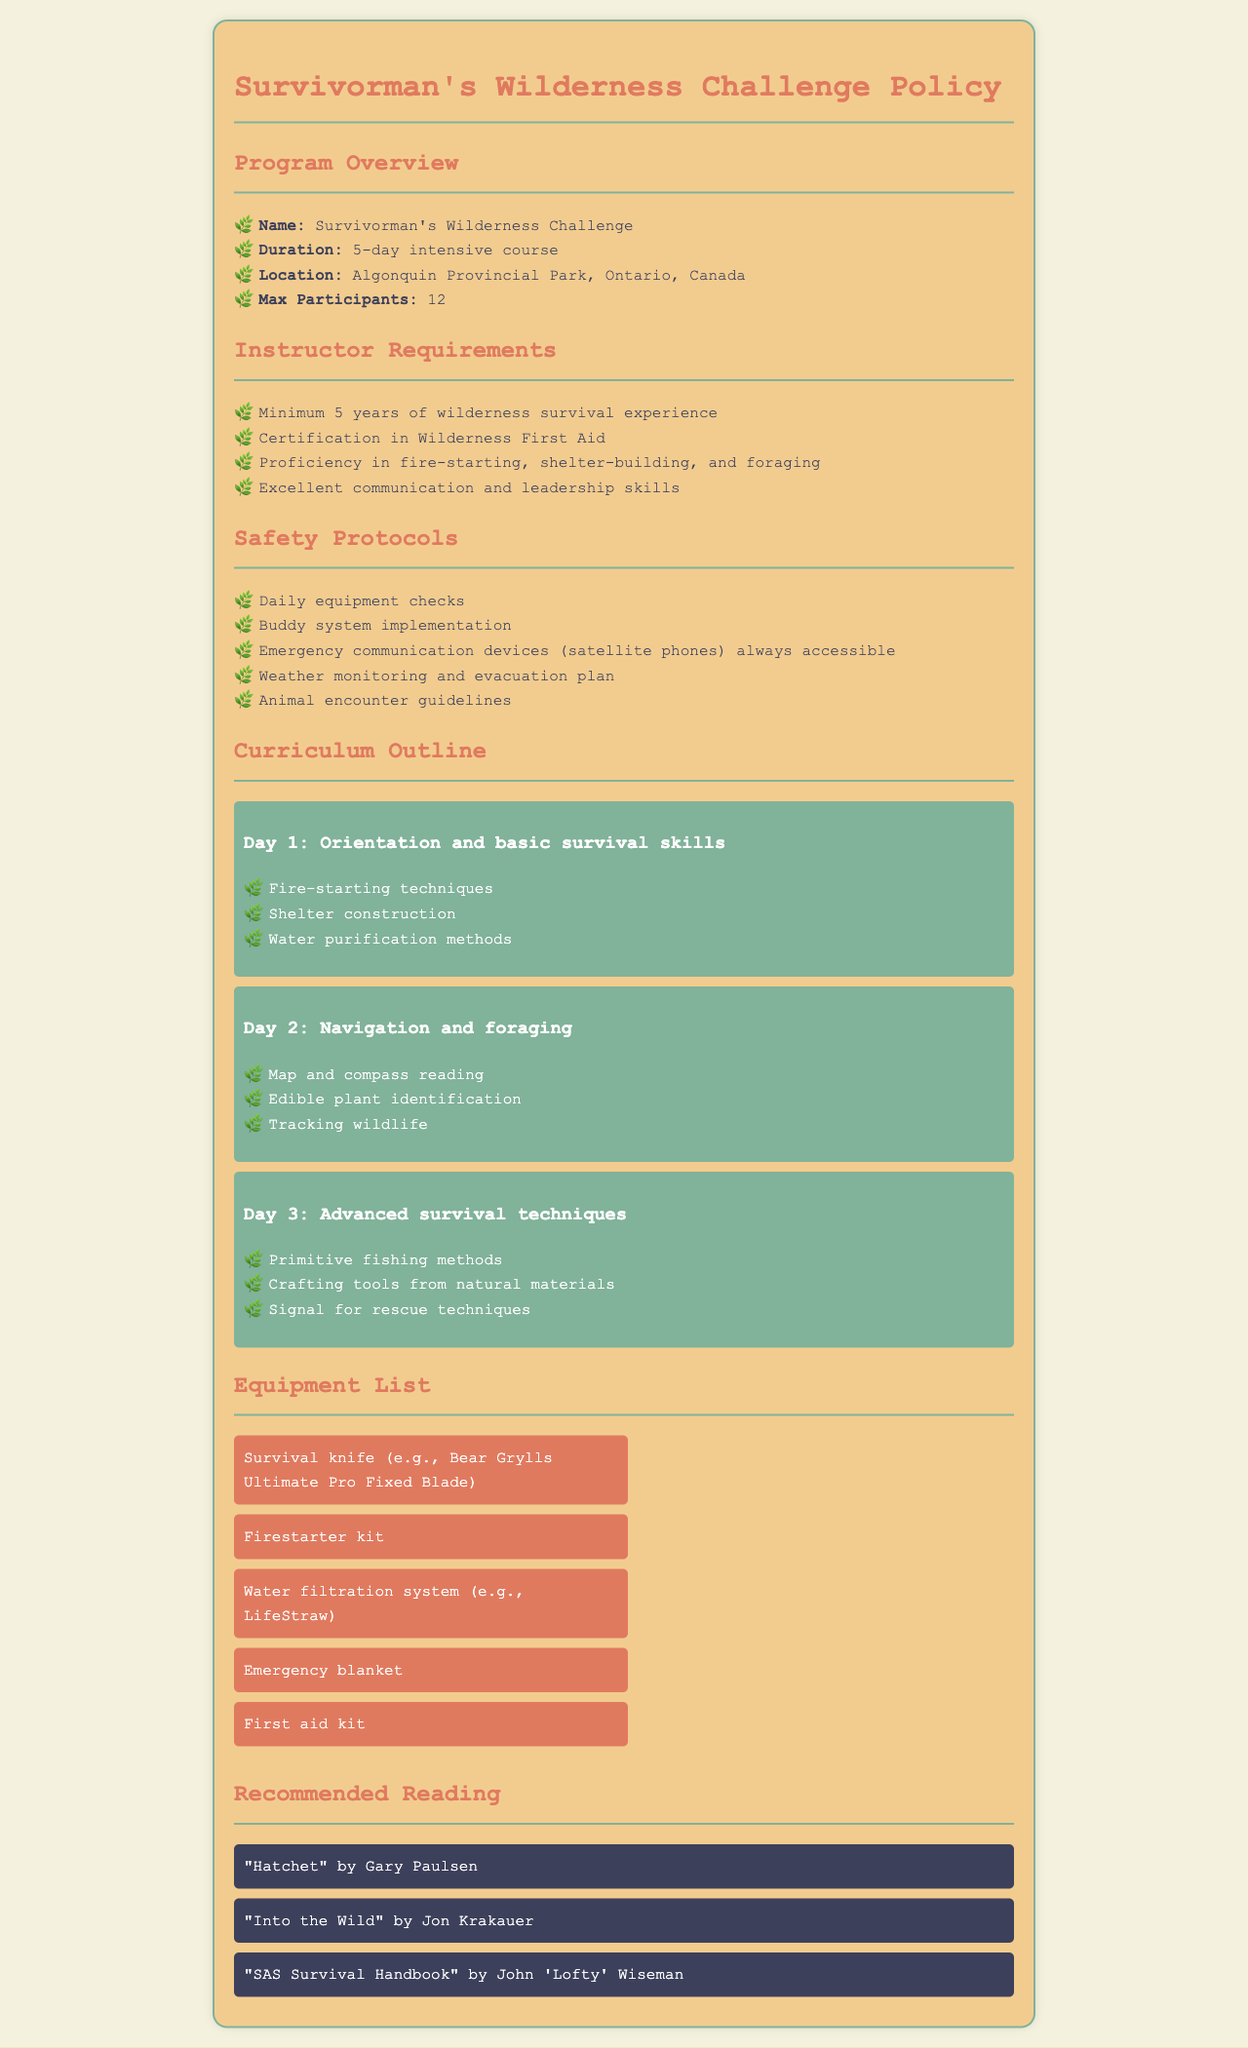what is the name of the program? The name of the program is provided in the document, which is "Survivorman's Wilderness Challenge."
Answer: Survivorman's Wilderness Challenge how many days is the training course? The duration of the training program is mentioned clearly as "5-day intensive course."
Answer: 5-day where is the training located? The document specifies the location of the program as "Algonquin Provincial Park, Ontario, Canada."
Answer: Algonquin Provincial Park, Ontario, Canada what is a requirement for instructors? The document lists various requirements for instructors, one of which includes having "Minimum 5 years of wilderness survival experience."
Answer: Minimum 5 years of wilderness survival experience what emergency equipment is always accessible? The document mentions the need for "Emergency communication devices (satellite phones) always accessible" as a safety protocol.
Answer: satellite phones which technique is taught on Day 1? The curriculum outline specifies that "Fire-starting techniques" are taught on Day 1.
Answer: Fire-starting techniques how many max participants are allowed? The document states the maximum number of participants as "12."
Answer: 12 name a recommended reading book. The document provides several titles, including "SAS Survival Handbook" by John 'Lofty' Wiseman.
Answer: SAS Survival Handbook what is one safety protocol mentioned? The document outlines multiple safety protocols, one of which is "Daily equipment checks."
Answer: Daily equipment checks 